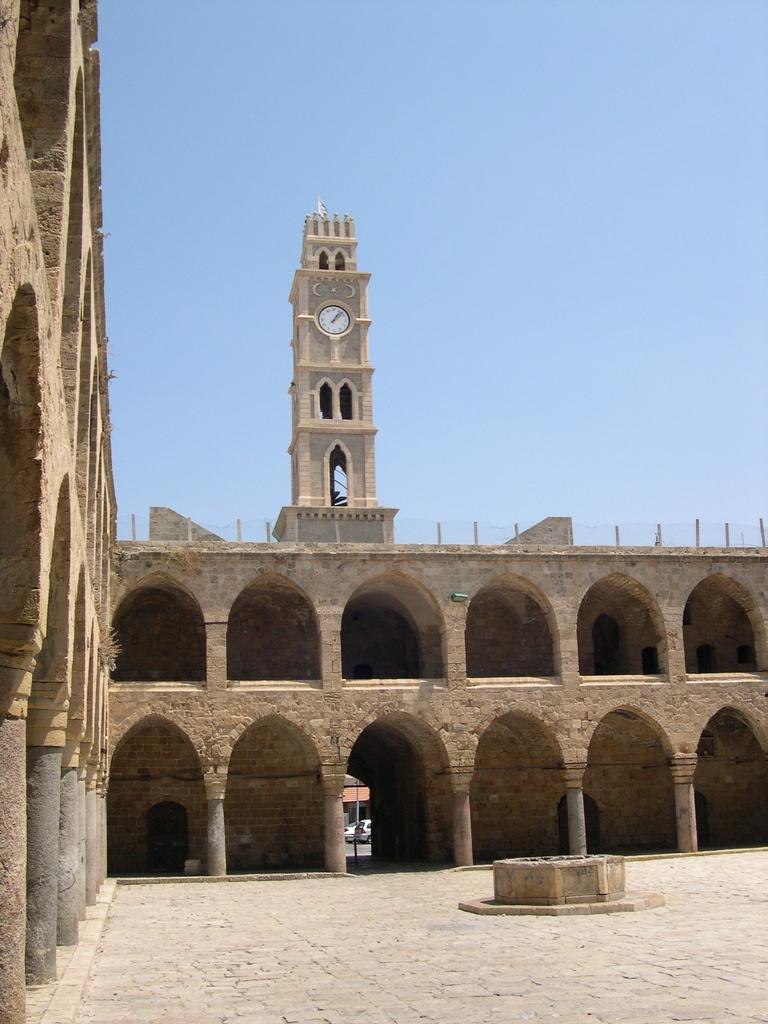What is the main subject of the image? There is a monument in the image. Can you describe the background of the image? There is a clock tower in the background of the image. What type of seed is being planted by the goat in the image? There is no goat or seed present in the image; it features a monument and a clock tower. What type of engine is powering the monument in the image? There is no engine present in the image; the monument is a stationary structure. 